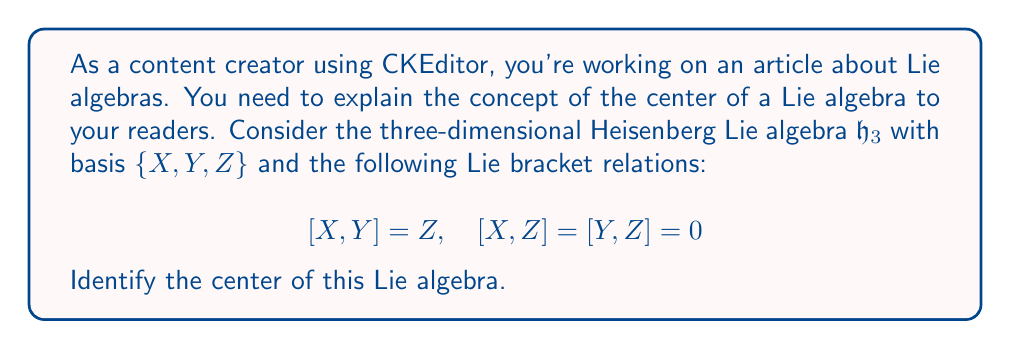Help me with this question. To identify the center of the Heisenberg Lie algebra $\mathfrak{h}_3$, we need to follow these steps:

1) Recall that the center of a Lie algebra $\mathfrak{g}$ is defined as:

   $$Z(\mathfrak{g}) = \{a \in \mathfrak{g} : [a,x] = 0 \text{ for all } x \in \mathfrak{g}\}$$

2) For $\mathfrak{h}_3$, let's consider a general element $a = \alpha X + \beta Y + \gamma Z$ where $\alpha, \beta, \gamma \in \mathbb{R}$.

3) We need to check when $[a,x] = 0$ for all $x \in \mathfrak{h}_3$. It's sufficient to check this condition for the basis elements $X, Y,$ and $Z$.

4) Let's compute each bracket:

   $[a,X] = [\alpha X + \beta Y + \gamma Z, X]$
   $= \alpha[X,X] + \beta[Y,X] + \gamma[Z,X]$
   $= -\beta Z$ (since $[X,X]=0, [Y,X]=-[X,Y]=-Z, [Z,X]=0$)

   $[a,Y] = [\alpha X + \beta Y + \gamma Z, Y]$
   $= \alpha[X,Y] + \beta[Y,Y] + \gamma[Z,Y]$
   $= \alpha Z$ (since $[X,Y]=Z, [Y,Y]=0, [Z,Y]=0$)

   $[a,Z] = [\alpha X + \beta Y + \gamma Z, Z] = 0$ (since $[X,Z]=[Y,Z]=[Z,Z]=0$)

5) For $a$ to be in the center, we need $[a,X]=[a,Y]=[a,Z]=0$. From the above calculations:

   $[a,X] = -\beta Z = 0 \implies \beta = 0$
   $[a,Y] = \alpha Z = 0 \implies \alpha = 0$
   $[a,Z] = 0$ (always true)

6) Therefore, the elements in the center have the form $\gamma Z$ where $\gamma \in \mathbb{R}$.
Answer: The center of the Heisenberg Lie algebra $\mathfrak{h}_3$ is $Z(\mathfrak{h}_3) = \{\gamma Z : \gamma \in \mathbb{R}\}$, which is the one-dimensional subspace spanned by $Z$. 